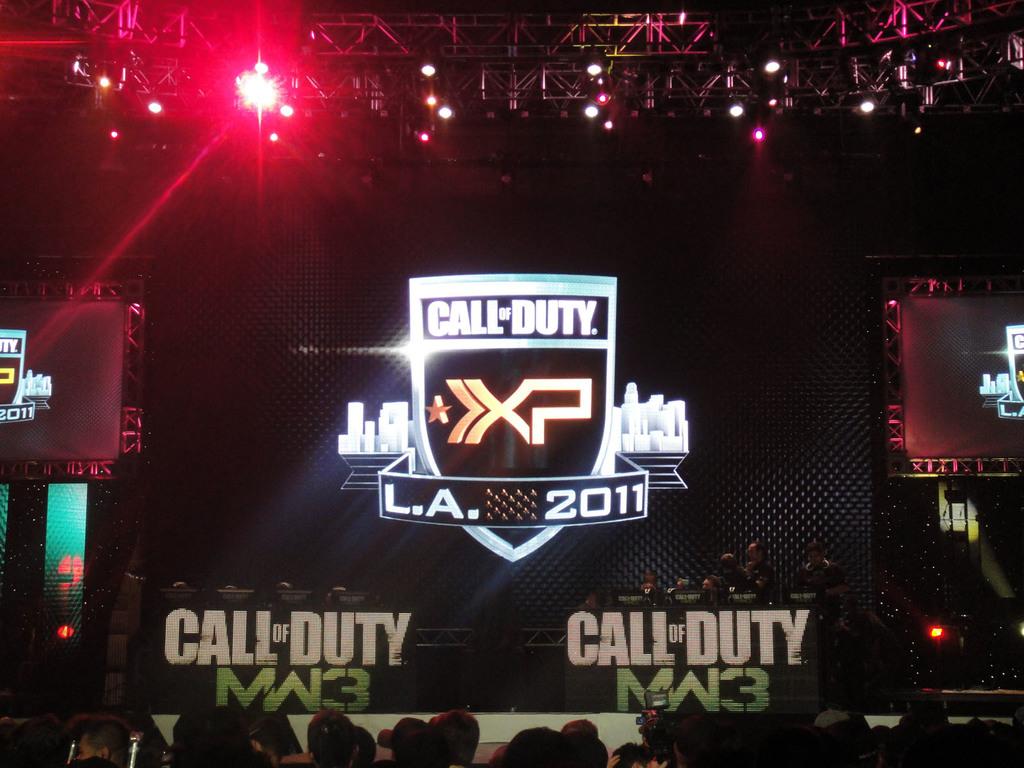What video game is being advertised?
Your response must be concise. Call of duty. What is the year?
Provide a short and direct response. 2011. 